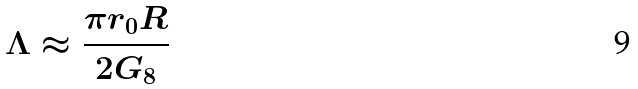<formula> <loc_0><loc_0><loc_500><loc_500>\Lambda \approx \frac { \pi r _ { 0 } R } { 2 G _ { 8 } }</formula> 